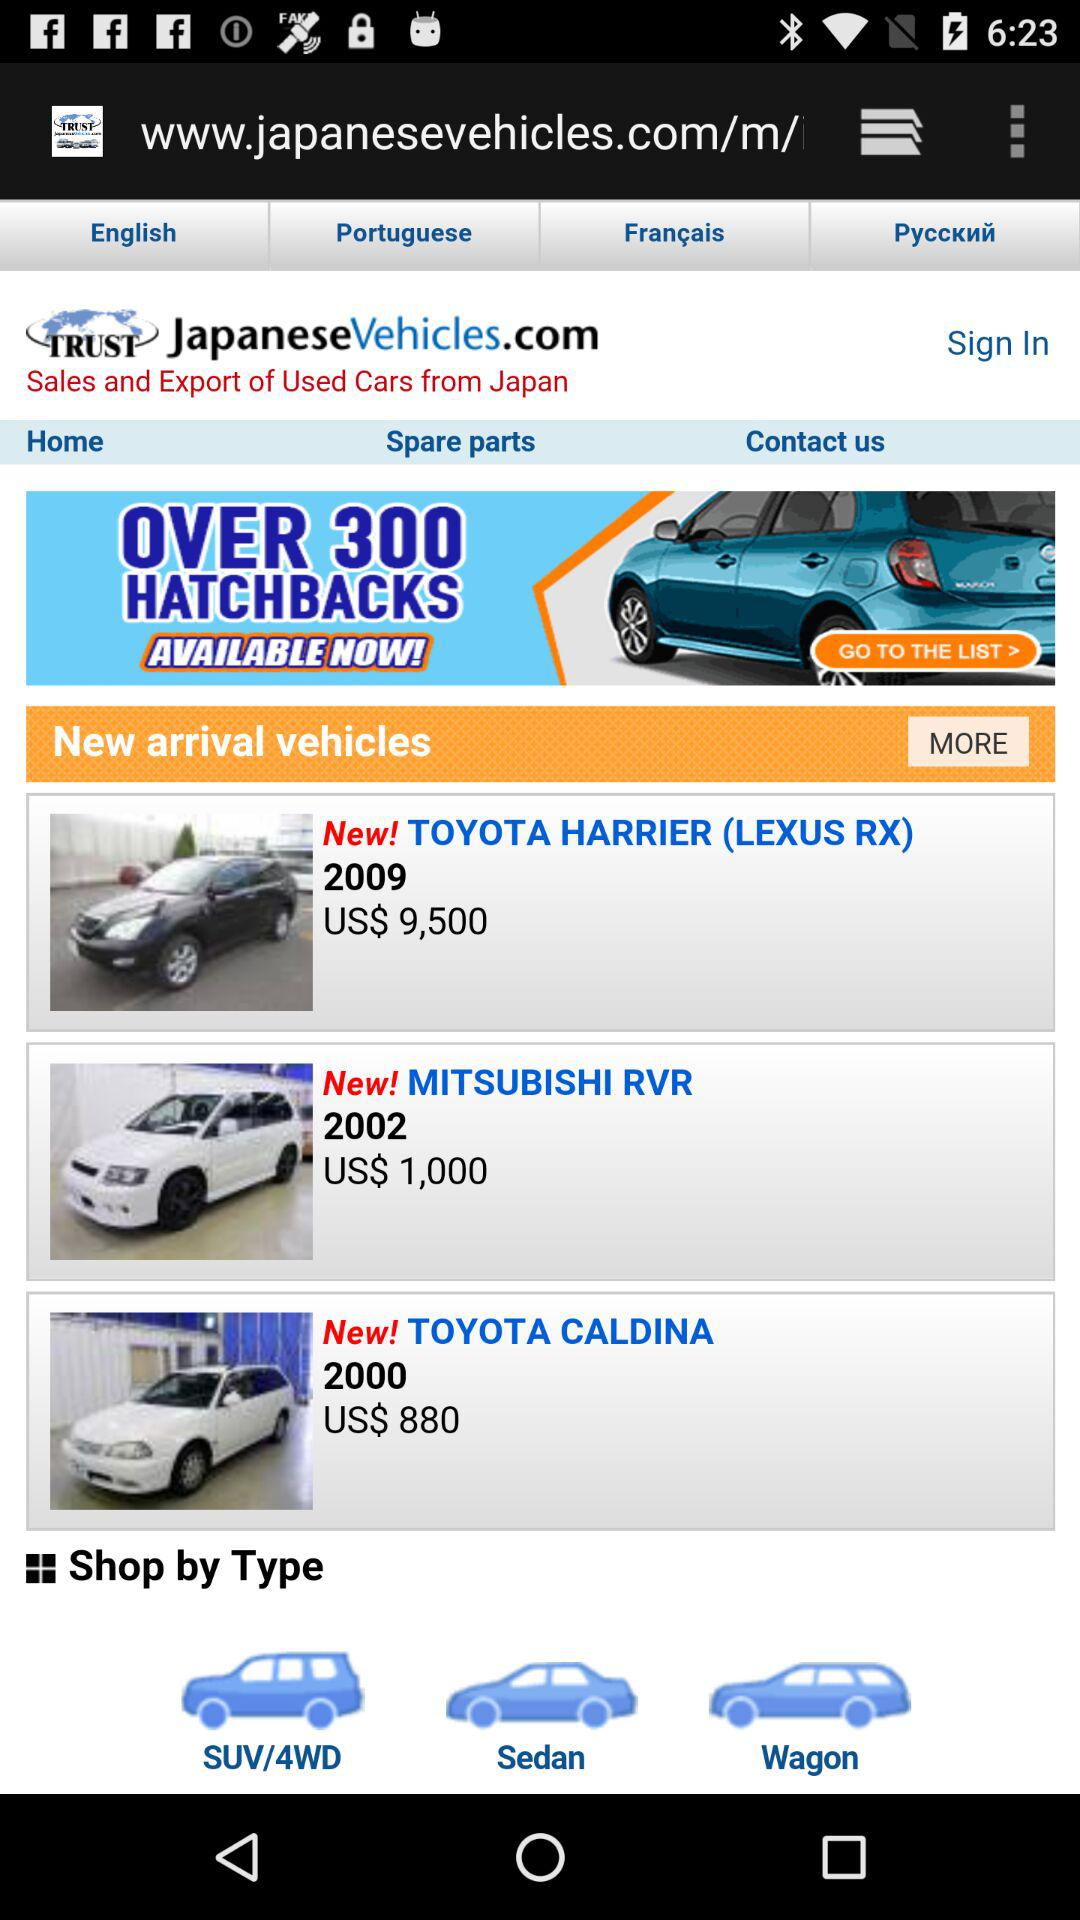What is the web address for the Japanese vehicles? The web address is www.japanesevehicles.com/m/. 